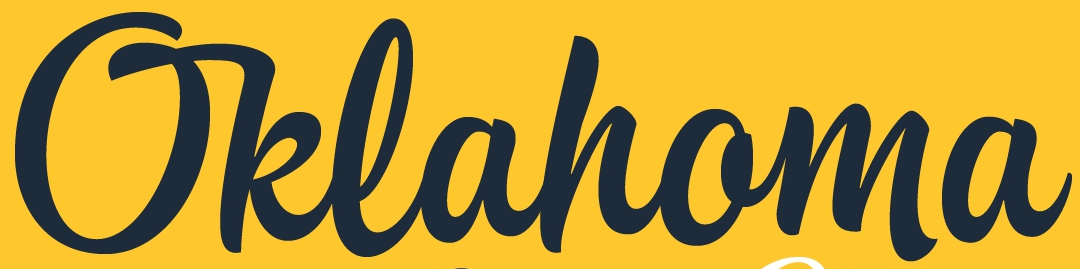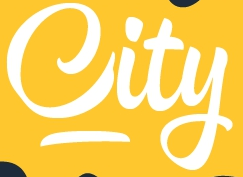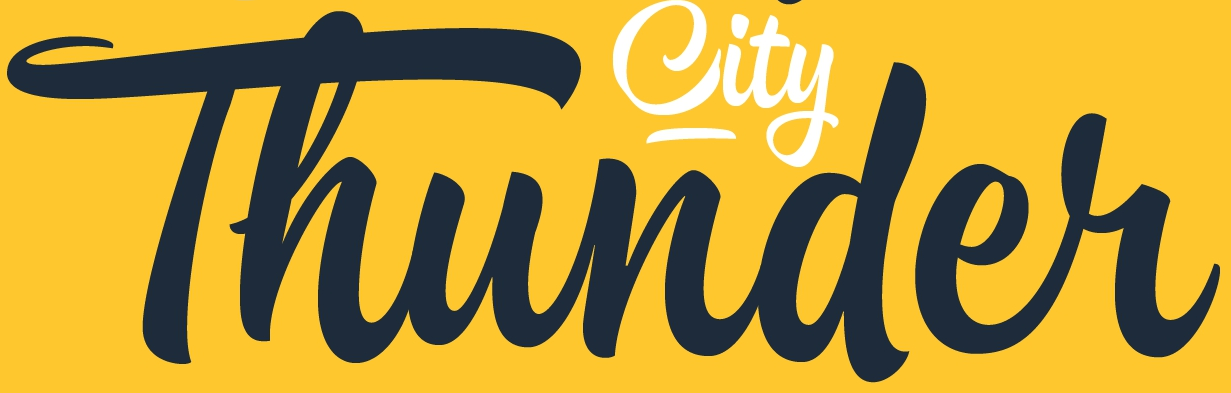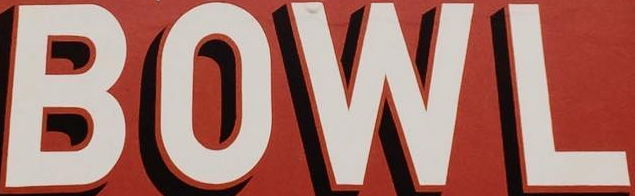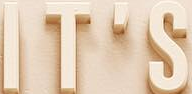Read the text content from these images in order, separated by a semicolon. Oklahoma; City; Thunder; BOWL; IT'S 